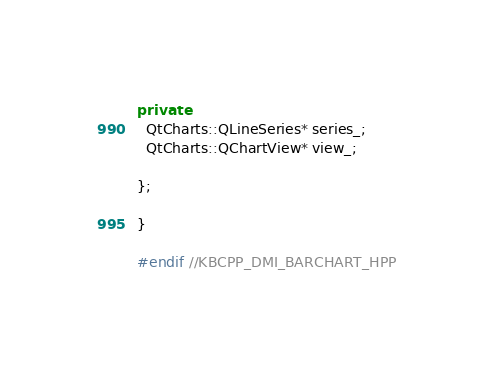Convert code to text. <code><loc_0><loc_0><loc_500><loc_500><_C++_>
private:
  QtCharts::QLineSeries* series_;
  QtCharts::QChartView* view_;

};

}

#endif //KBCPP_DMI_BARCHART_HPP
</code> 